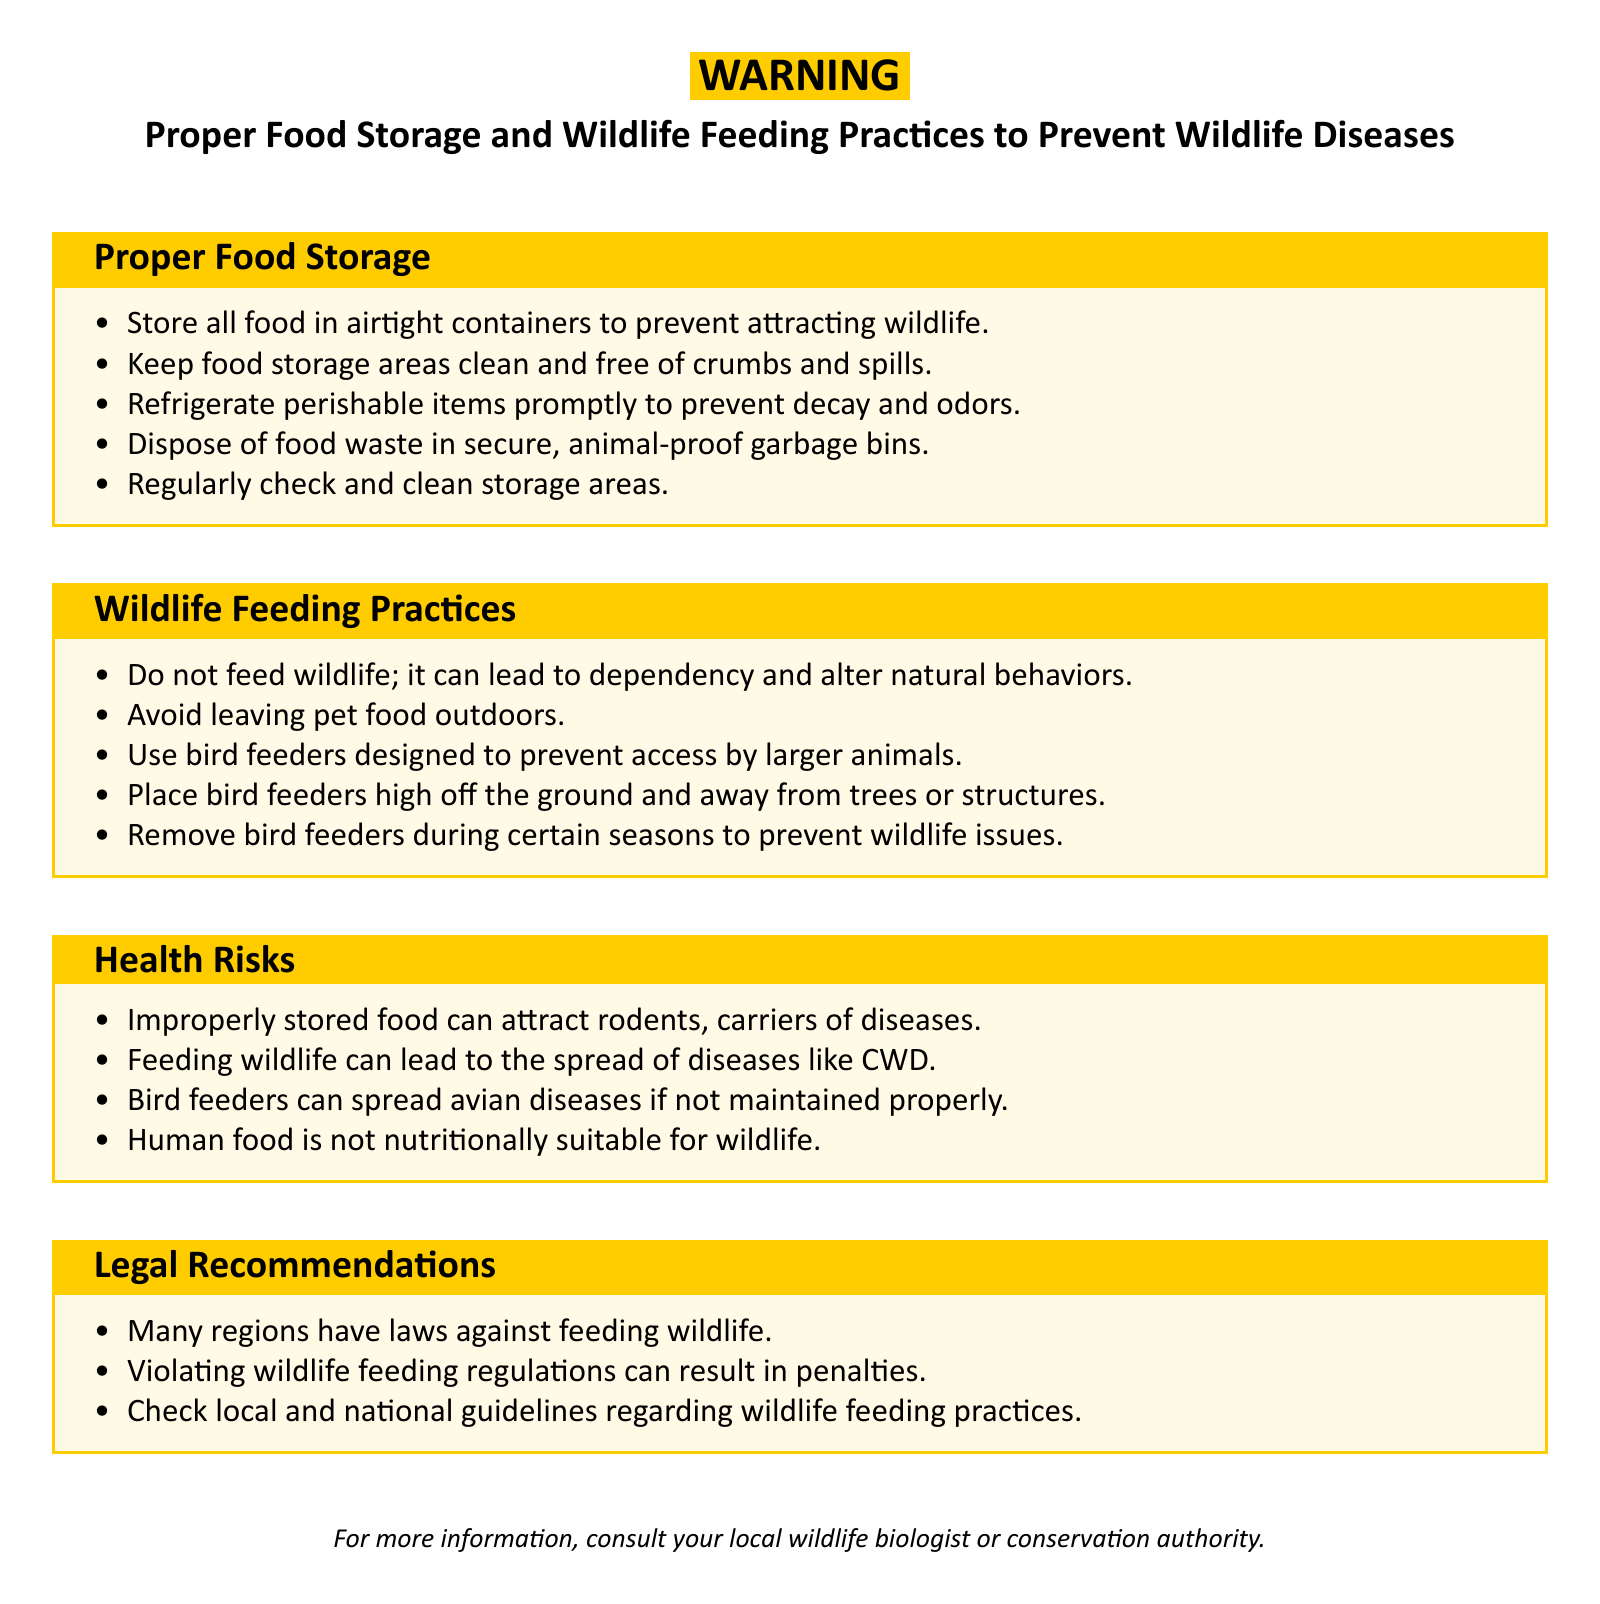What should all food be stored in? The document states that all food should be stored in airtight containers to prevent attracting wildlife.
Answer: Airtight containers What is a health risk of improperly stored food? The document mentions that improperly stored food can attract rodents, which are carriers of diseases.
Answer: Attract rodents What should you not do regarding wildlife feeding practices? The document advises not to feed wildlife as it can lead to dependency and alter natural behaviors.
Answer: Do not feed wildlife Where should bird feeders be placed? The document states that bird feeders should be placed high off the ground and away from trees or structures.
Answer: High off the ground What can result from violating wildlife feeding regulations? According to the document, violating wildlife feeding regulations can result in penalties.
Answer: Penalties What is one reason to remove bird feeders during certain seasons? The document suggests that removing bird feeders can prevent wildlife issues.
Answer: Prevent wildlife issues What type of food is not nutritionally suitable for wildlife? The document specifies that human food is not nutritionally suitable for wildlife.
Answer: Human food 